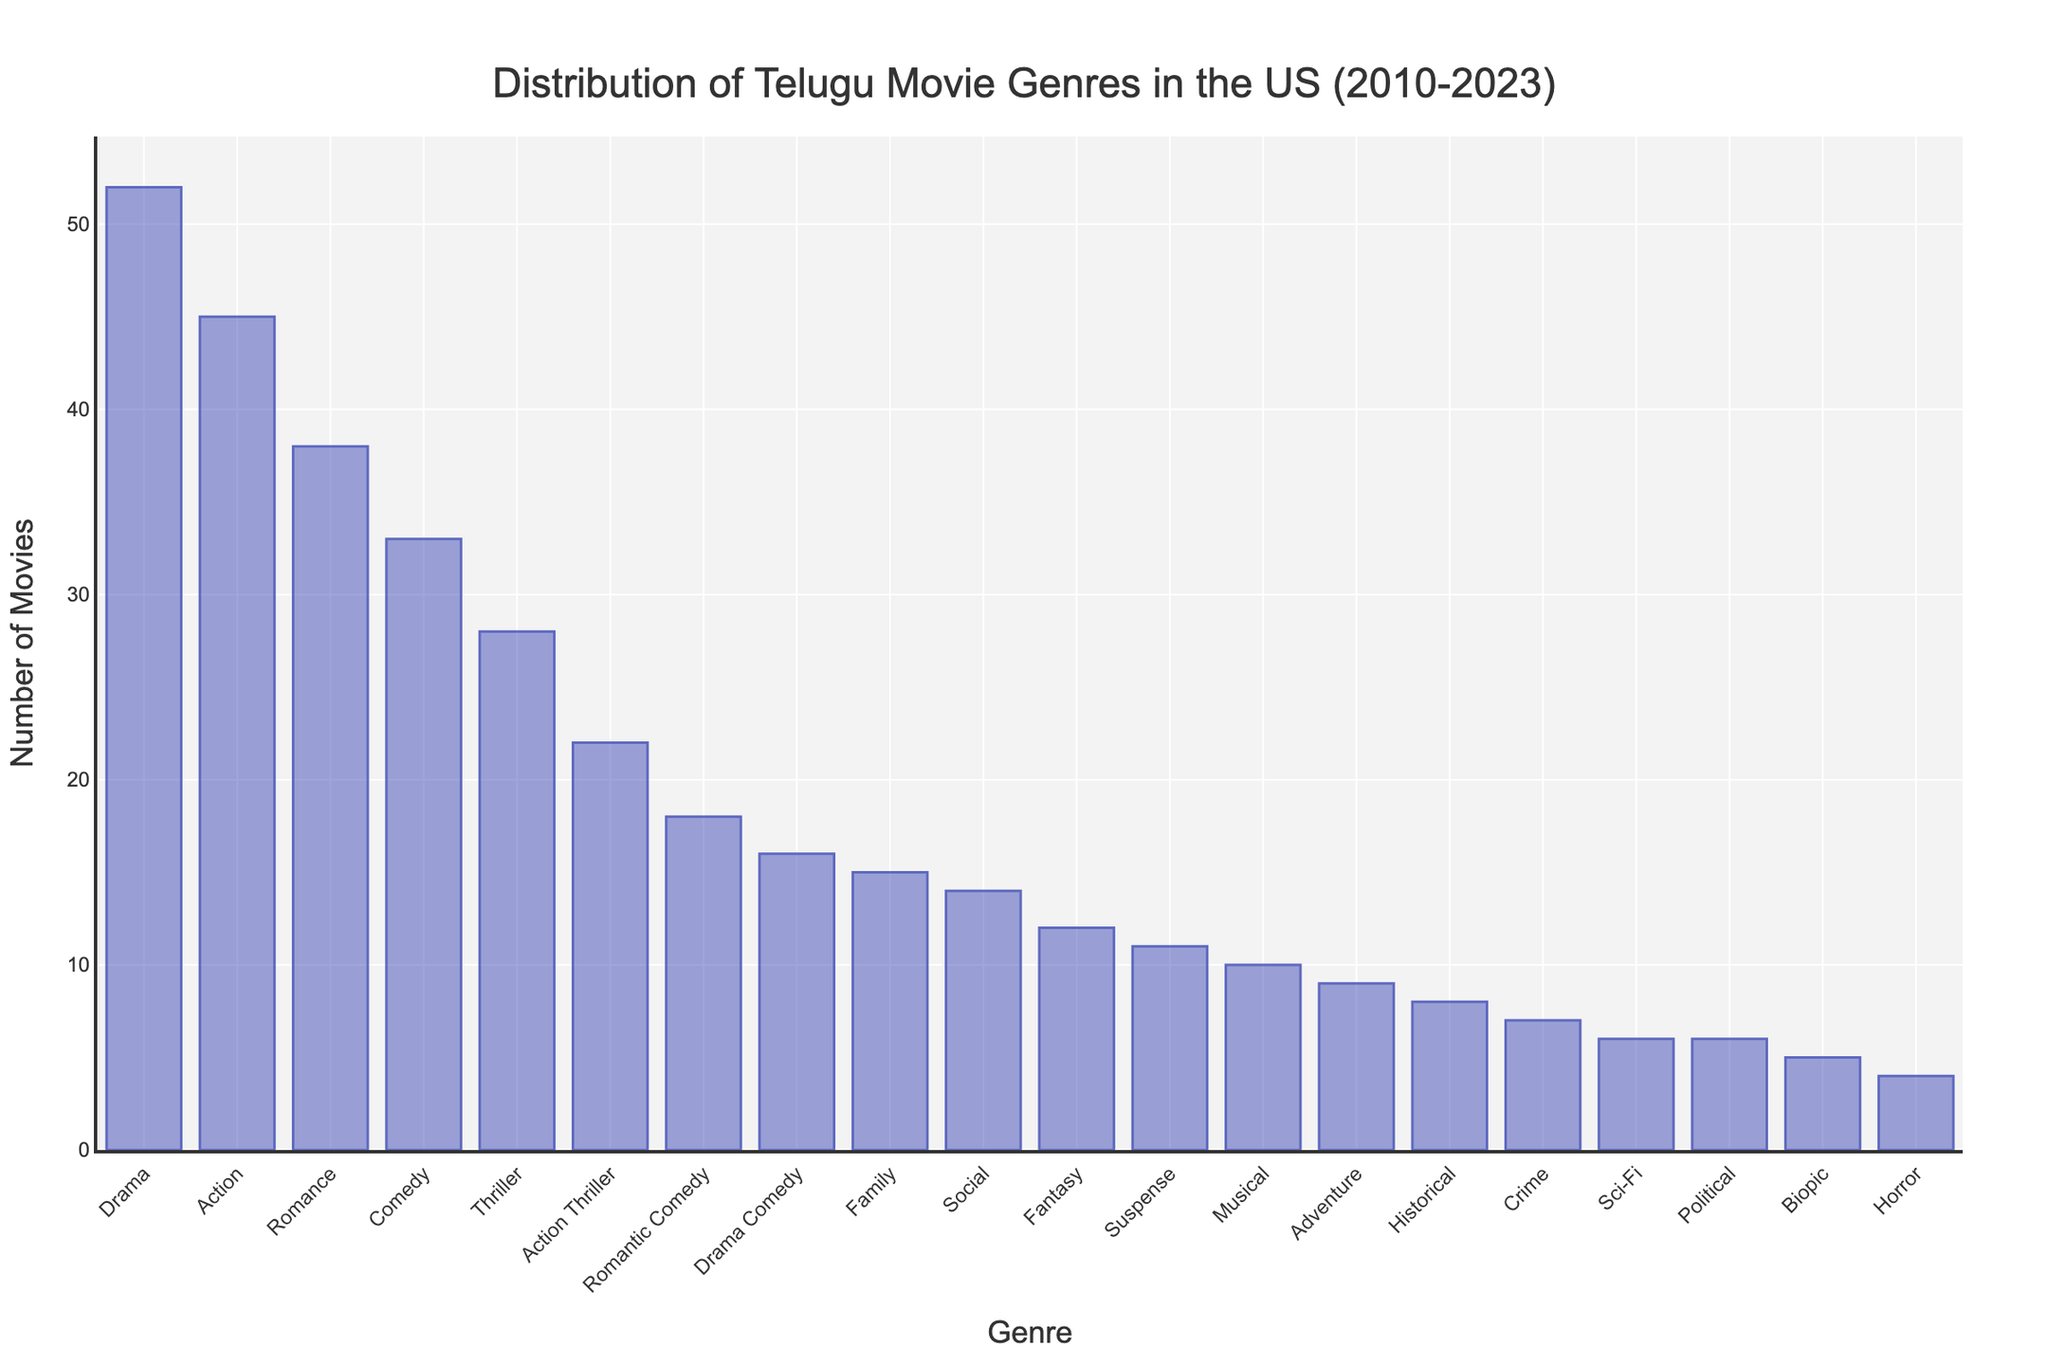Which genre has the highest number of Telugu movie releases in the US from 2010 to 2023? The tallest bar represents 'Drama' with 52 movies, indicating it's the genre with the highest number of releases.
Answer: Drama Which two genres have an equal number of movies released, and what is that number? Both Political and Sci-Fi genres have bars of the same height, indicating 6 movies released each.
Answer: Political and Sci-Fi, 6 What is the total number of movies released for the Comedy and Drama Comedy genres? The height of the Comedy bar represents 33 movies, and the Drama Comedy bar represents 16 movies. Summing these, 33 + 16 = 49.
Answer: 49 How many more Action movies were released compared to Thriller movies? The Action bar shows 45 movies, and the Thriller bar shows 28 movies. The difference is 45 - 28 = 17.
Answer: 17 Which genre has the least number of movie releases, and how many? The shortest bar represents the Horror genre with 4 movies, indicating it's the least.
Answer: Horror, 4 How many total movies were released across the Romance and Romantic Comedy genres? The Romance bar shows 38 movies, and the Romantic Comedy bar shows 18 movies. Adding these together, 38 + 18 = 56.
Answer: 56 Which genre has slightly more releases: Suspense or Fantasy, and by how many? The Suspense bar shows 11 movies, while the Fantasy bar shows 12 movies. The difference is 12 - 11 = 1.
Answer: Fantasy, 1 What's the combined total of movies released for the top 3 genres? The top 3 genres by bar height are Drama (52), Action (45), and Romance (38). Summing these, 52 + 45 + 38 = 135.
Answer: 135 